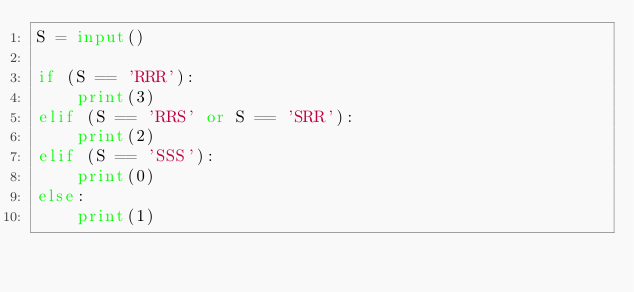Convert code to text. <code><loc_0><loc_0><loc_500><loc_500><_Python_>S = input()

if (S == 'RRR'):
    print(3)
elif (S == 'RRS' or S == 'SRR'):
    print(2)
elif (S == 'SSS'):
    print(0)
else:
    print(1)</code> 